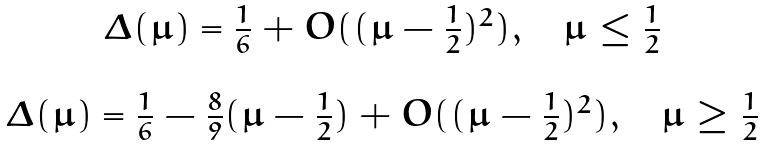Convert formula to latex. <formula><loc_0><loc_0><loc_500><loc_500>\begin{array} { c } \Delta ( \mu ) = \frac { 1 } { 6 } + O ( ( \mu - \frac { 1 } { 2 } ) ^ { 2 } ) , \quad \mu \leq \frac { 1 } { 2 } \\ \\ \Delta ( \mu ) = \frac { 1 } { 6 } - \frac { 8 } { 9 } ( \mu - \frac { 1 } { 2 } ) + O ( ( \mu - \frac { 1 } { 2 } ) ^ { 2 } ) , \quad \mu \geq \frac { 1 } { 2 } \end{array}</formula> 